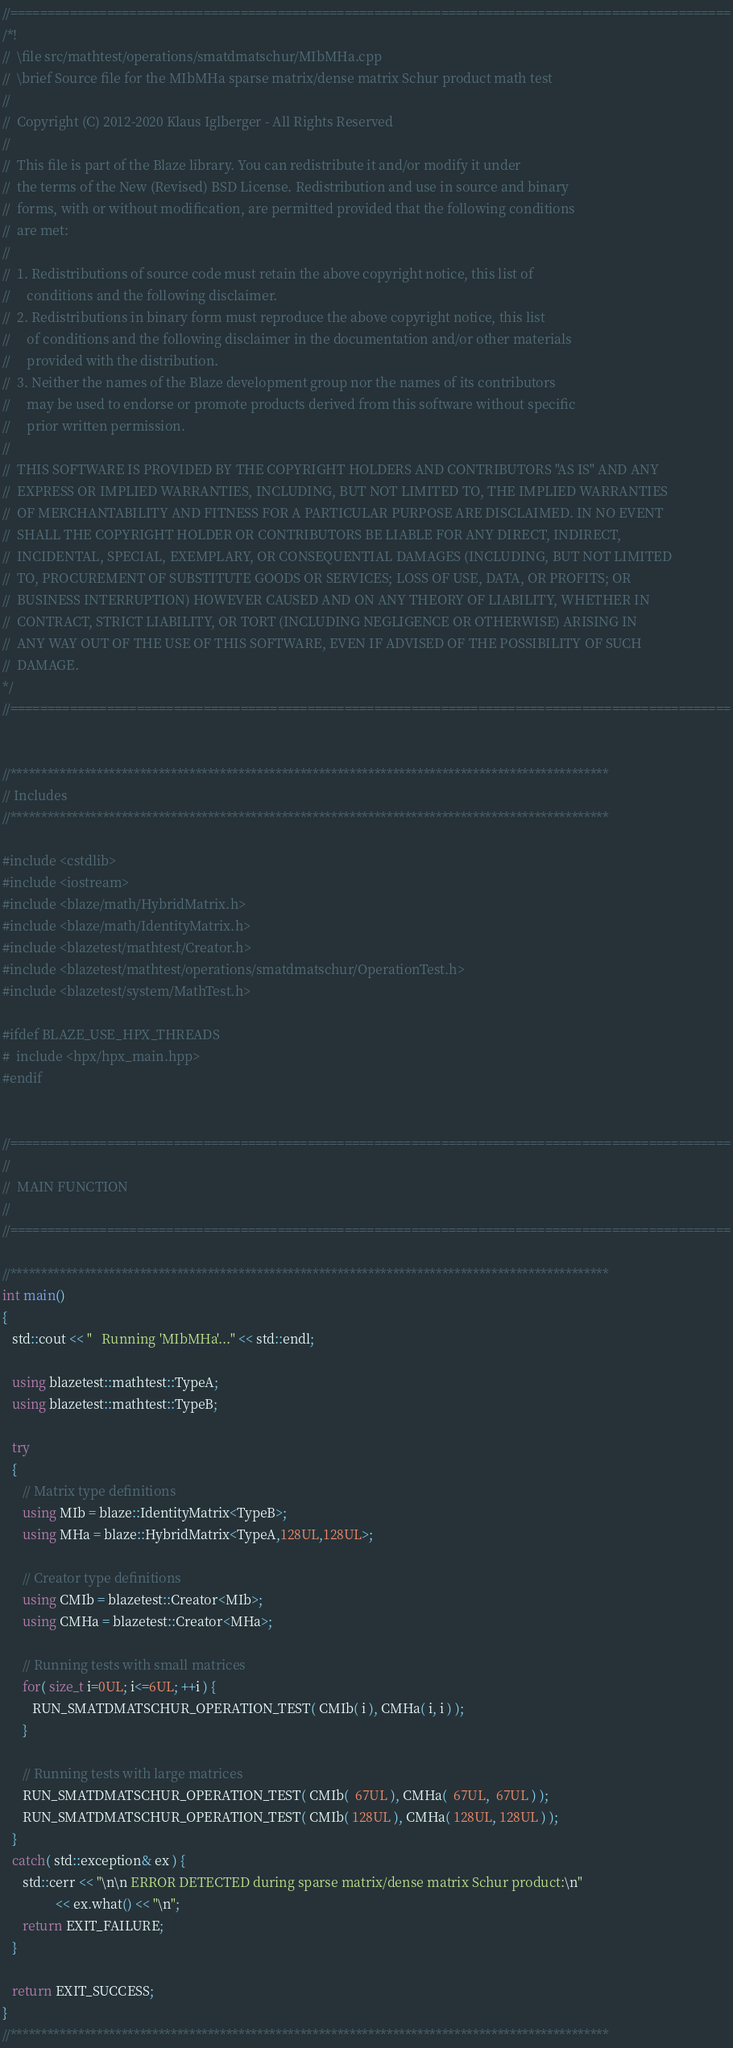Convert code to text. <code><loc_0><loc_0><loc_500><loc_500><_C++_>//=================================================================================================
/*!
//  \file src/mathtest/operations/smatdmatschur/MIbMHa.cpp
//  \brief Source file for the MIbMHa sparse matrix/dense matrix Schur product math test
//
//  Copyright (C) 2012-2020 Klaus Iglberger - All Rights Reserved
//
//  This file is part of the Blaze library. You can redistribute it and/or modify it under
//  the terms of the New (Revised) BSD License. Redistribution and use in source and binary
//  forms, with or without modification, are permitted provided that the following conditions
//  are met:
//
//  1. Redistributions of source code must retain the above copyright notice, this list of
//     conditions and the following disclaimer.
//  2. Redistributions in binary form must reproduce the above copyright notice, this list
//     of conditions and the following disclaimer in the documentation and/or other materials
//     provided with the distribution.
//  3. Neither the names of the Blaze development group nor the names of its contributors
//     may be used to endorse or promote products derived from this software without specific
//     prior written permission.
//
//  THIS SOFTWARE IS PROVIDED BY THE COPYRIGHT HOLDERS AND CONTRIBUTORS "AS IS" AND ANY
//  EXPRESS OR IMPLIED WARRANTIES, INCLUDING, BUT NOT LIMITED TO, THE IMPLIED WARRANTIES
//  OF MERCHANTABILITY AND FITNESS FOR A PARTICULAR PURPOSE ARE DISCLAIMED. IN NO EVENT
//  SHALL THE COPYRIGHT HOLDER OR CONTRIBUTORS BE LIABLE FOR ANY DIRECT, INDIRECT,
//  INCIDENTAL, SPECIAL, EXEMPLARY, OR CONSEQUENTIAL DAMAGES (INCLUDING, BUT NOT LIMITED
//  TO, PROCUREMENT OF SUBSTITUTE GOODS OR SERVICES; LOSS OF USE, DATA, OR PROFITS; OR
//  BUSINESS INTERRUPTION) HOWEVER CAUSED AND ON ANY THEORY OF LIABILITY, WHETHER IN
//  CONTRACT, STRICT LIABILITY, OR TORT (INCLUDING NEGLIGENCE OR OTHERWISE) ARISING IN
//  ANY WAY OUT OF THE USE OF THIS SOFTWARE, EVEN IF ADVISED OF THE POSSIBILITY OF SUCH
//  DAMAGE.
*/
//=================================================================================================


//*************************************************************************************************
// Includes
//*************************************************************************************************

#include <cstdlib>
#include <iostream>
#include <blaze/math/HybridMatrix.h>
#include <blaze/math/IdentityMatrix.h>
#include <blazetest/mathtest/Creator.h>
#include <blazetest/mathtest/operations/smatdmatschur/OperationTest.h>
#include <blazetest/system/MathTest.h>

#ifdef BLAZE_USE_HPX_THREADS
#  include <hpx/hpx_main.hpp>
#endif


//=================================================================================================
//
//  MAIN FUNCTION
//
//=================================================================================================

//*************************************************************************************************
int main()
{
   std::cout << "   Running 'MIbMHa'..." << std::endl;

   using blazetest::mathtest::TypeA;
   using blazetest::mathtest::TypeB;

   try
   {
      // Matrix type definitions
      using MIb = blaze::IdentityMatrix<TypeB>;
      using MHa = blaze::HybridMatrix<TypeA,128UL,128UL>;

      // Creator type definitions
      using CMIb = blazetest::Creator<MIb>;
      using CMHa = blazetest::Creator<MHa>;

      // Running tests with small matrices
      for( size_t i=0UL; i<=6UL; ++i ) {
         RUN_SMATDMATSCHUR_OPERATION_TEST( CMIb( i ), CMHa( i, i ) );
      }

      // Running tests with large matrices
      RUN_SMATDMATSCHUR_OPERATION_TEST( CMIb(  67UL ), CMHa(  67UL,  67UL ) );
      RUN_SMATDMATSCHUR_OPERATION_TEST( CMIb( 128UL ), CMHa( 128UL, 128UL ) );
   }
   catch( std::exception& ex ) {
      std::cerr << "\n\n ERROR DETECTED during sparse matrix/dense matrix Schur product:\n"
                << ex.what() << "\n";
      return EXIT_FAILURE;
   }

   return EXIT_SUCCESS;
}
//*************************************************************************************************
</code> 